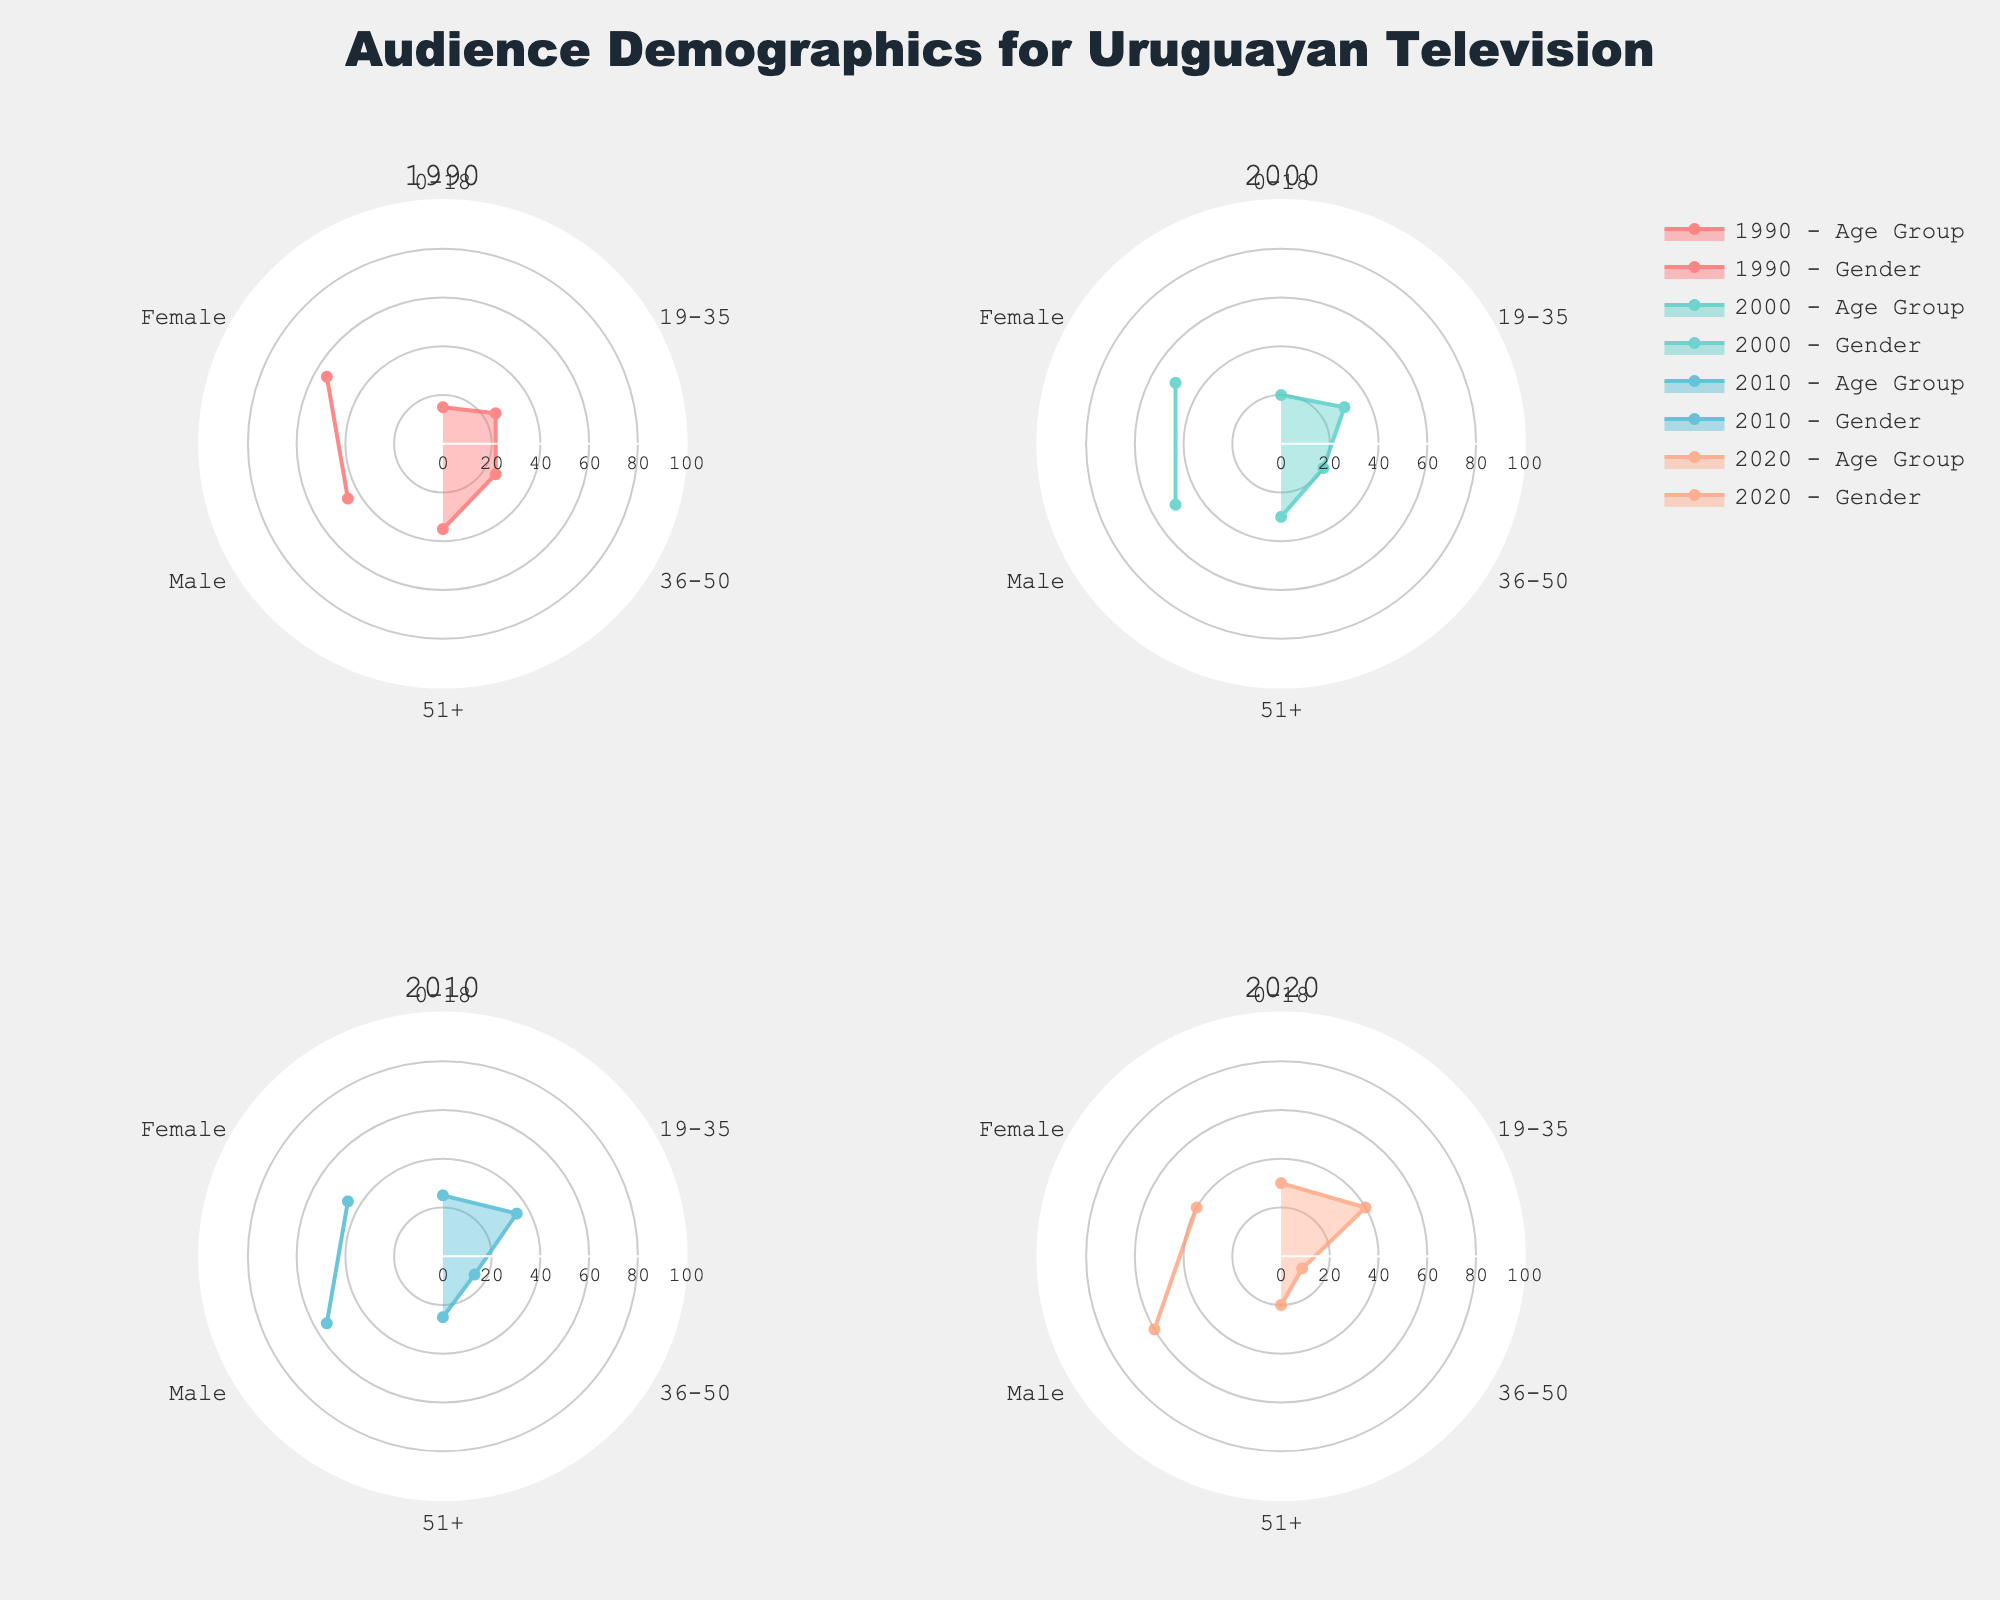What is the title of the figure? The title is generally found at the top of the plot and provides a summary of what the figure represents.
Answer: Audience Demographics for Uruguayan Television Which year shows an equal gender distribution? By looking at the radar charts for gender distribution, find the year where the Male and Female segments have the same values.
Answer: 2020 What age group had the highest percentage of viewers in 1990? Check the radar chart for the year 1990 and look at the 'Age Group' segmentation to find the category with the largest value.
Answer: 51+ Which year had the highest percentage of female viewers? Compare the percentage values for female viewers across all years from the radar charts.
Answer: 1990 How has the viewer percentage for the '19-35' age group changed from 1990 to 2020? Note the percentage for the '19-35' age group in 1990, and then find the same percentage in 2020 and calculate the difference. The viewers in the '19-35' group increased from 25% to 40%, an increase of 15%.
Answer: Increased by 15% Which gender saw a higher viewership percentage in 2000? Examine the 2000 radar chart for gender distribution to identify the higher value between Male and Female.
Answer: Female What is the difference between urban and rural viewers in 2010? Locate the radar chart for 2010, find the values for Urban and Rural viewers, and compute the difference between these values. Urban: 55%, Rural: 45%, Difference: 55% - 45% = 10%.
Answer: 10% Compare the '0-18' age group's viewership from 1990 to 2020. Look at the '0-18' values in 1990 and 2020, and note if the viewership increased or decreased. 1990: 15%, 2020: 30%, thus an increase.
Answer: Increased Which year had the highest percentage of male viewers? Check the male viewer percentages across all years represented in the radar charts and identify the highest value.
Answer: 2020 In which year did the '36-50' age group have the lowest percentage? Compare the '36-50' percentages across all years to find the lowest value. The '36-50' age group in 2020 had the lowest percentage of 10%.
Answer: 2020 